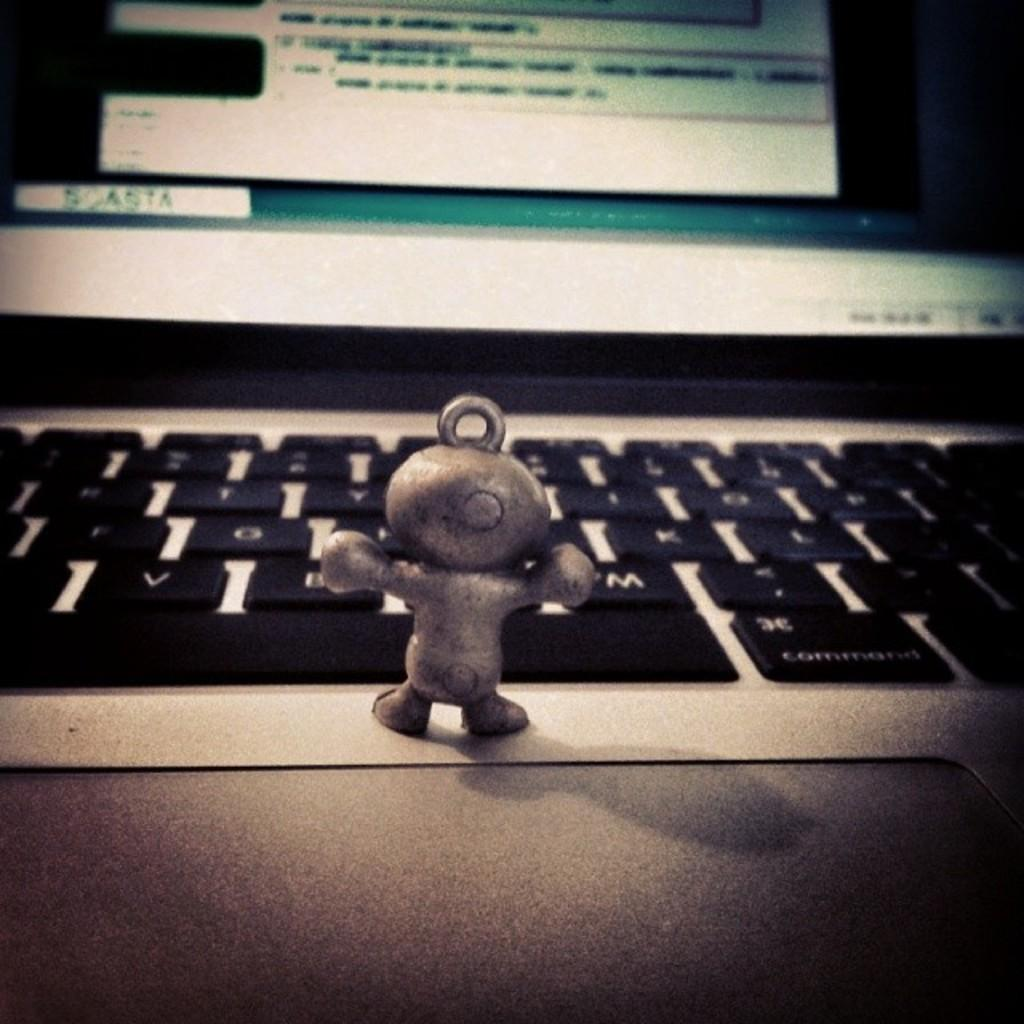What is placed on top of the laptop in the image? There is a toy on a laptop in the image. Can you describe the background of the image? The background of the image is blurred. What type of gun can be seen in the image? There is no gun present in the image; it features a toy on a laptop with a blurred background. 